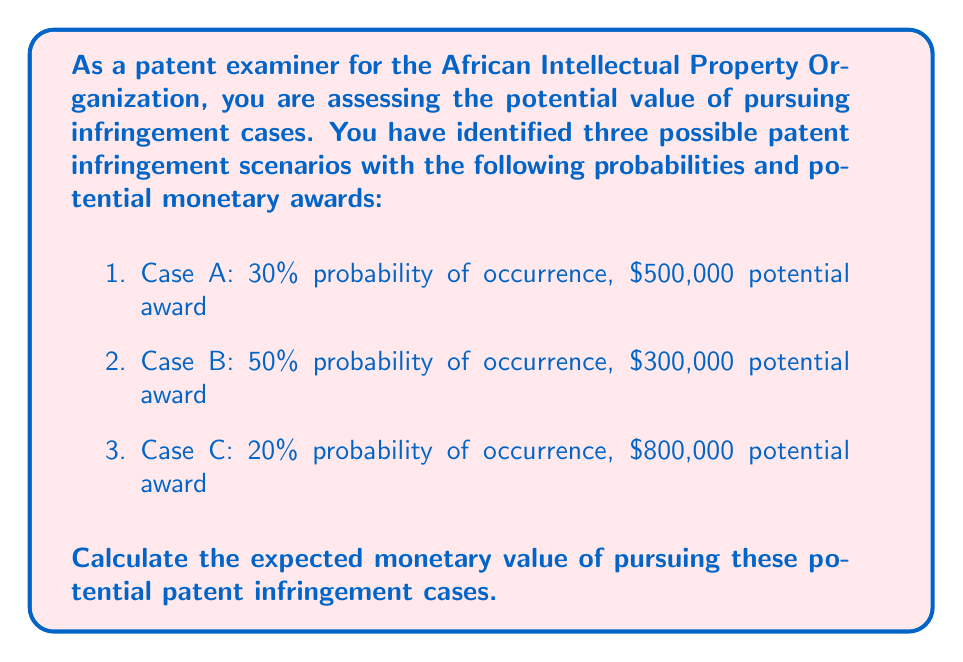Solve this math problem. To calculate the expected monetary value (EMV) of the potential patent infringement cases, we need to:

1. Calculate the EMV for each case individually
2. Sum up the individual EMVs to get the total EMV

Step 1: Calculate EMV for each case

The formula for expected value is:
$$ EMV = P(event) \times Value(event) $$

Case A:
$$ EMV_A = 0.30 \times \$500,000 = \$150,000 $$

Case B:
$$ EMV_B = 0.50 \times \$300,000 = \$150,000 $$

Case C:
$$ EMV_C = 0.20 \times \$800,000 = \$160,000 $$

Step 2: Sum up the individual EMVs

Total EMV = $EMV_A + EMV_B + EMV_C$
$$ Total EMV = \$150,000 + \$150,000 + \$160,000 = \$460,000 $$

Therefore, the expected monetary value of pursuing these potential patent infringement cases is $460,000.
Answer: $460,000 